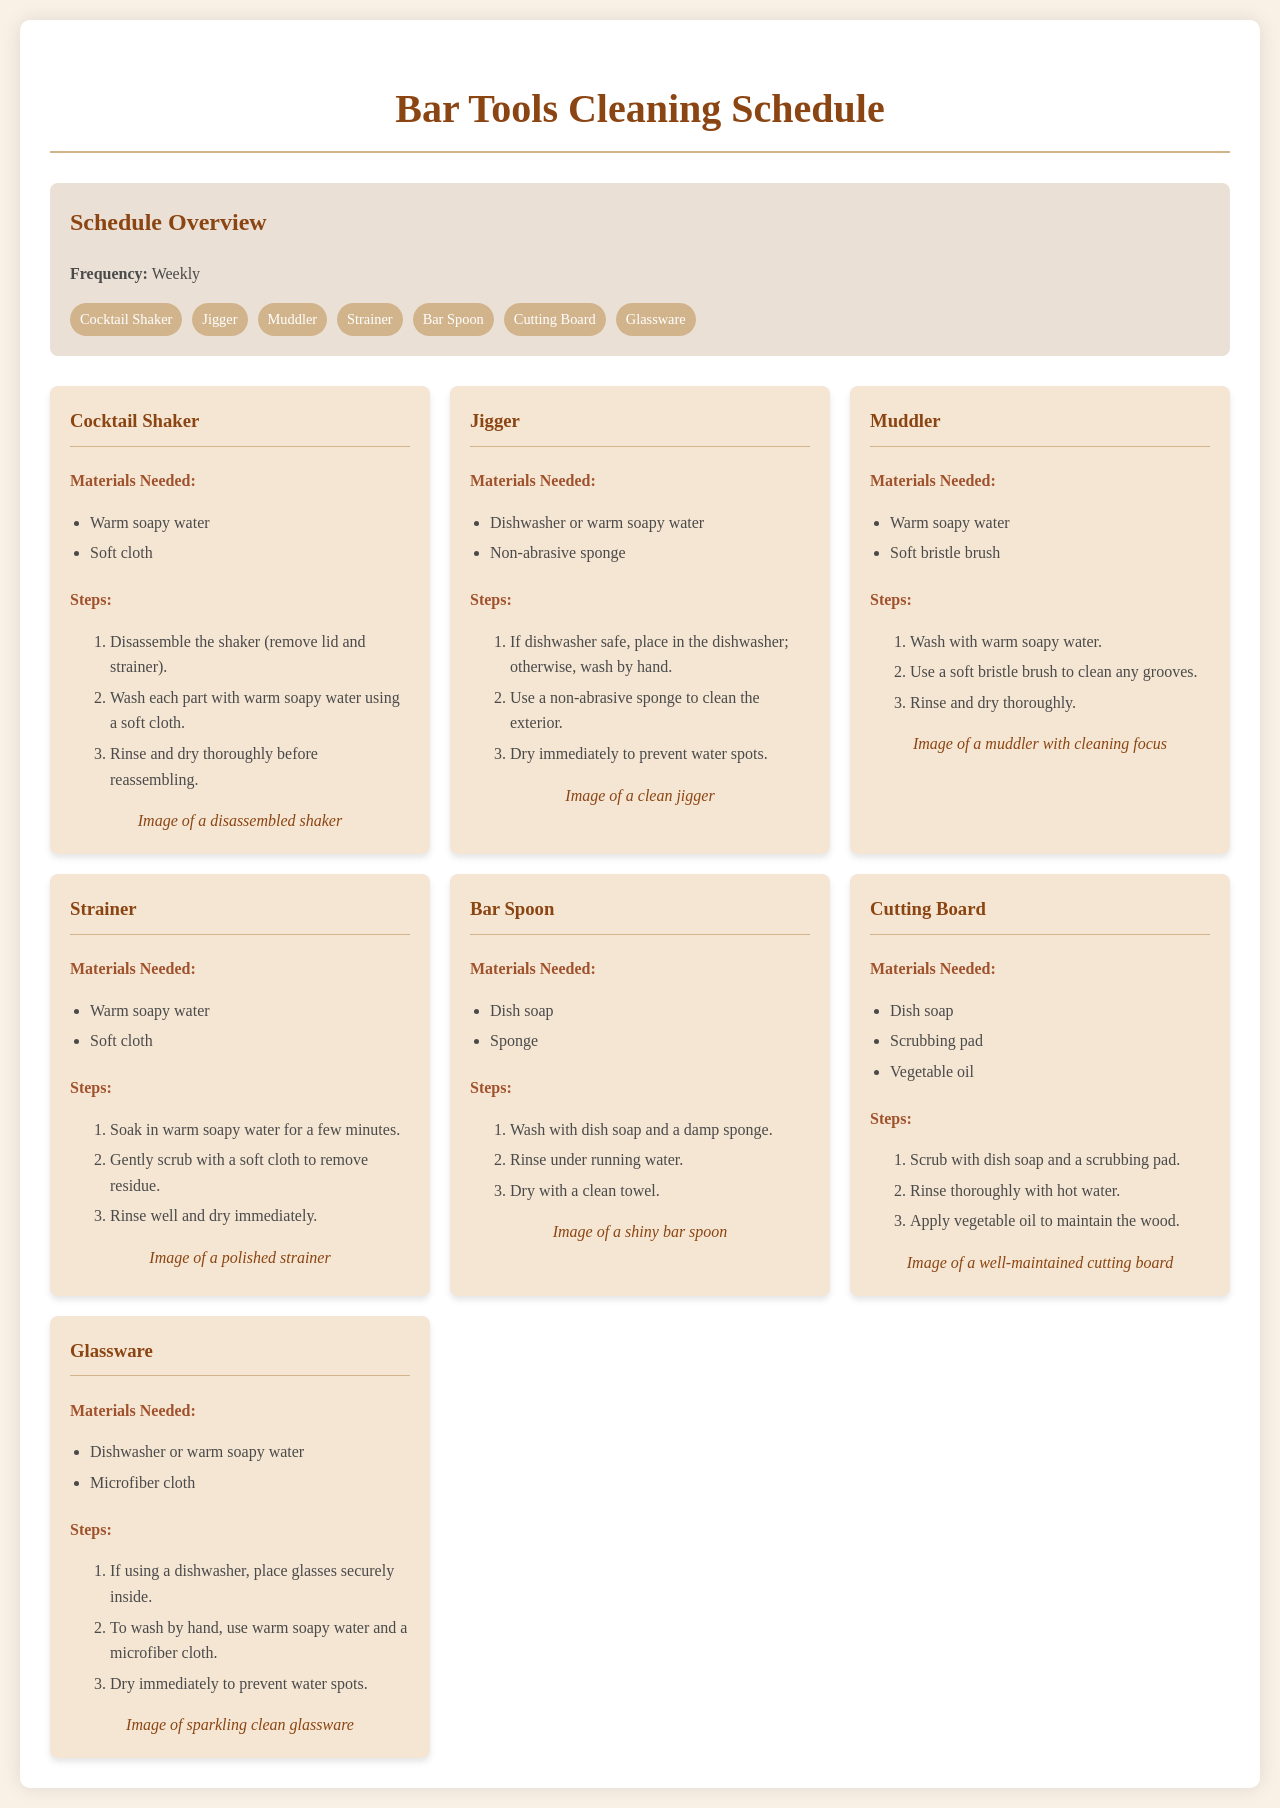What is the frequency of the cleaning schedule? The cleaning schedule states that it should be followed weekly.
Answer: Weekly How many tools are listed in the schedule? The document lists seven bar tools included in the cleaning schedule.
Answer: Seven What is the first step for cleaning the cocktail shaker? The first step for cleaning the cocktail shaker is to disassemble it by removing the lid and strainer.
Answer: Disassemble Which tool requires a soft bristle brush for cleaning? The muddler is the tool that requires a soft bristle brush for cleaning grooves.
Answer: Muddler What materials are needed to clean the cutting board? The cutting board requires dish soap, a scrubbing pad, and vegetable oil for proper cleaning.
Answer: Dish soap, scrubbing pad, vegetable oil What is the last step for cleaning glassware? The last step for cleaning glassware is to dry it immediately to prevent water spots.
Answer: Dry immediately What type of sponge should be used for cleaning a jigger? A non-abrasive sponge should be used to clean the exterior of the jigger.
Answer: Non-abrasive sponge Which tool has an image focused on maintaining wood? The cutting board has an image focused on maintaining wood through oil application.
Answer: Cutting board 